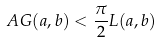Convert formula to latex. <formula><loc_0><loc_0><loc_500><loc_500>A G ( a , b ) < \frac { \pi } { 2 } L ( a , b )</formula> 